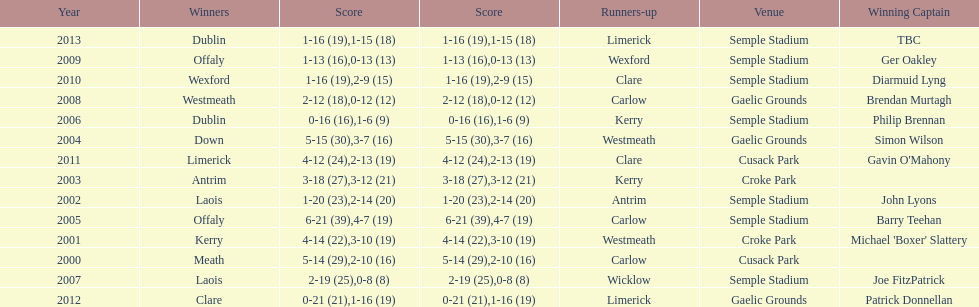How many victors were there at semple stadium? 7. 